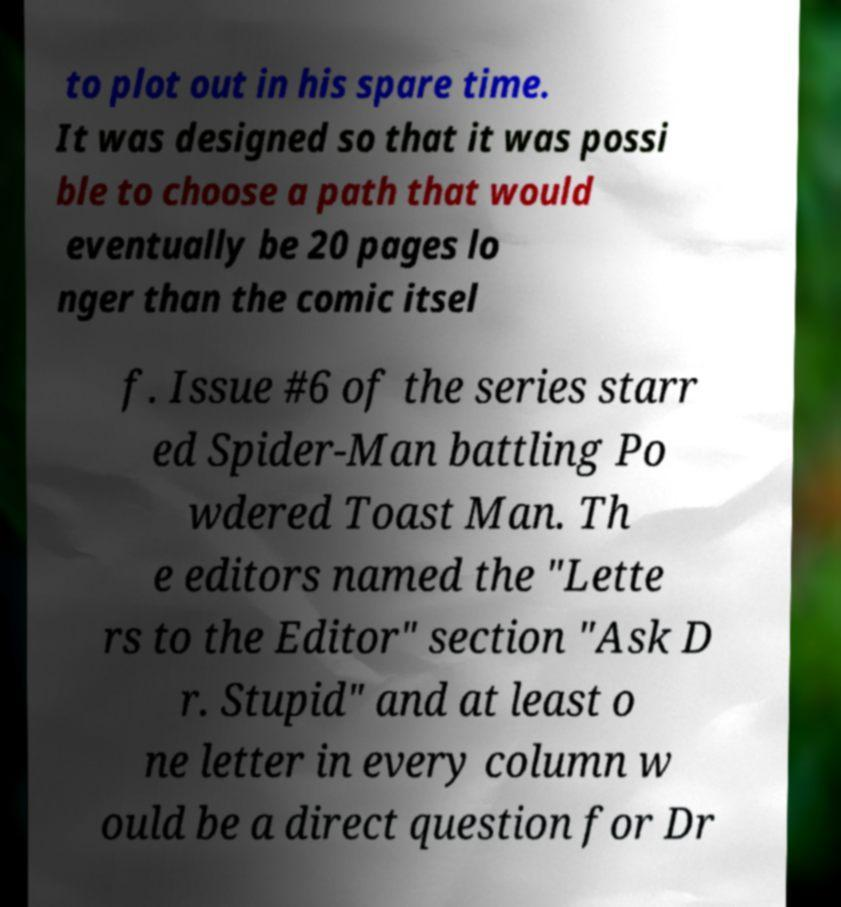There's text embedded in this image that I need extracted. Can you transcribe it verbatim? to plot out in his spare time. It was designed so that it was possi ble to choose a path that would eventually be 20 pages lo nger than the comic itsel f. Issue #6 of the series starr ed Spider-Man battling Po wdered Toast Man. Th e editors named the "Lette rs to the Editor" section "Ask D r. Stupid" and at least o ne letter in every column w ould be a direct question for Dr 